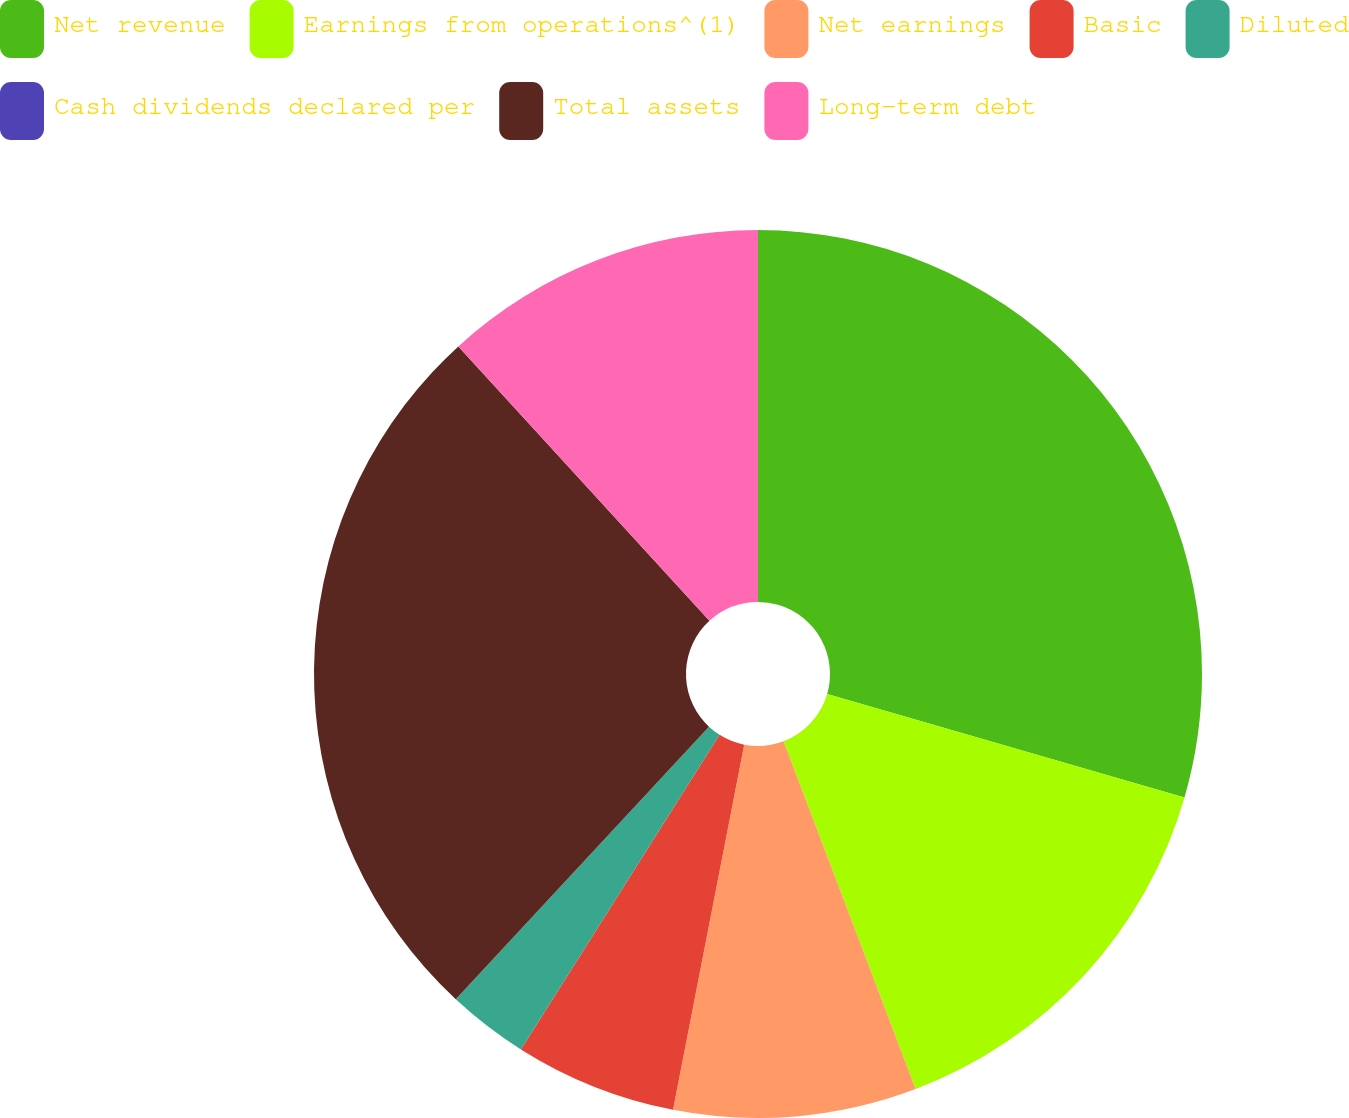<chart> <loc_0><loc_0><loc_500><loc_500><pie_chart><fcel>Net revenue<fcel>Earnings from operations^(1)<fcel>Net earnings<fcel>Basic<fcel>Diluted<fcel>Cash dividends declared per<fcel>Total assets<fcel>Long-term debt<nl><fcel>29.48%<fcel>14.74%<fcel>8.84%<fcel>5.9%<fcel>2.95%<fcel>0.0%<fcel>26.29%<fcel>11.79%<nl></chart> 